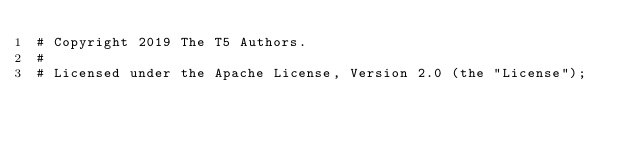<code> <loc_0><loc_0><loc_500><loc_500><_Python_># Copyright 2019 The T5 Authors.
#
# Licensed under the Apache License, Version 2.0 (the "License");</code> 